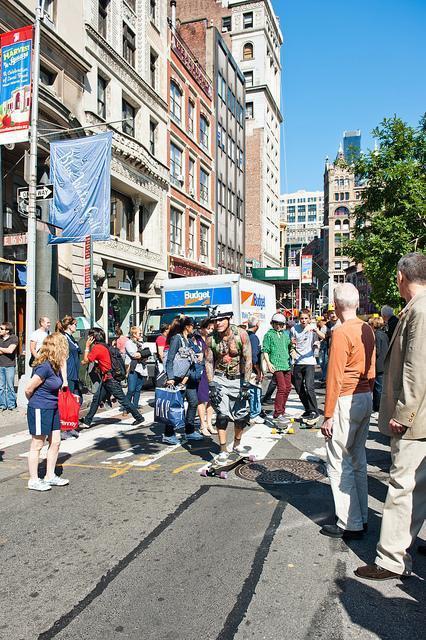How many people are there?
Give a very brief answer. 8. 